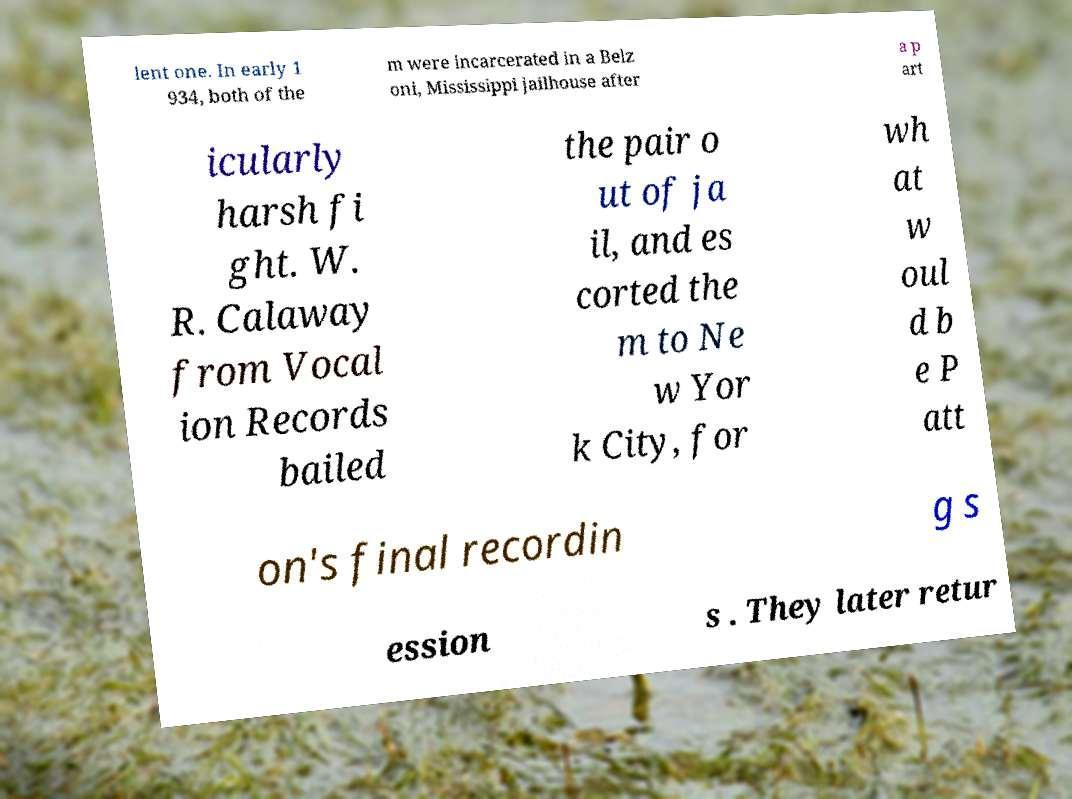Can you read and provide the text displayed in the image?This photo seems to have some interesting text. Can you extract and type it out for me? lent one. In early 1 934, both of the m were incarcerated in a Belz oni, Mississippi jailhouse after a p art icularly harsh fi ght. W. R. Calaway from Vocal ion Records bailed the pair o ut of ja il, and es corted the m to Ne w Yor k City, for wh at w oul d b e P att on's final recordin g s ession s . They later retur 